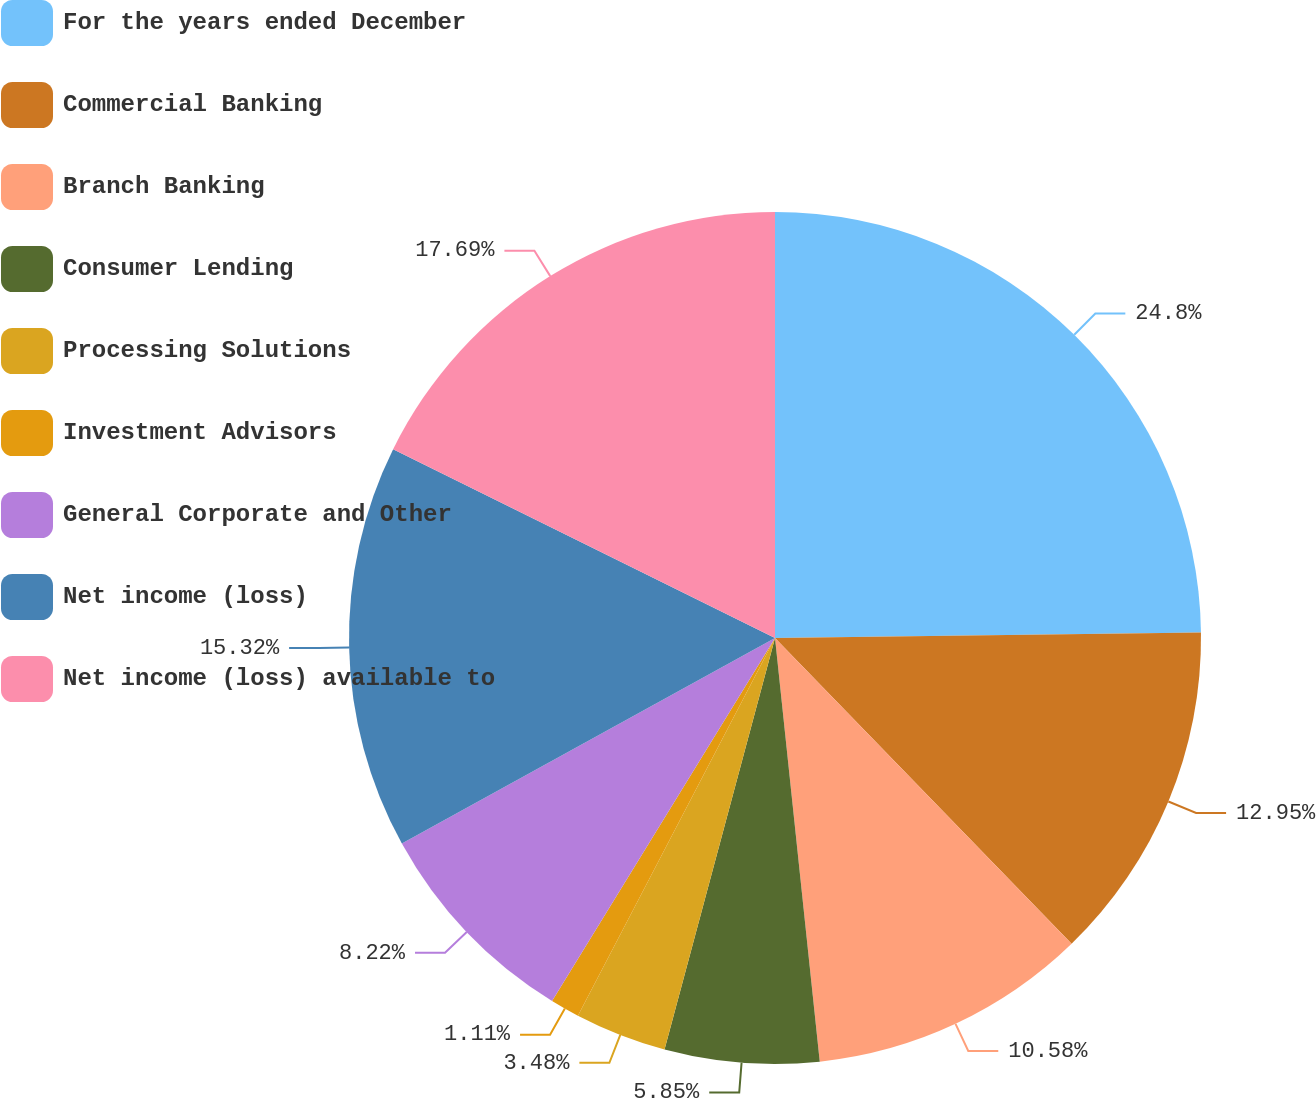<chart> <loc_0><loc_0><loc_500><loc_500><pie_chart><fcel>For the years ended December<fcel>Commercial Banking<fcel>Branch Banking<fcel>Consumer Lending<fcel>Processing Solutions<fcel>Investment Advisors<fcel>General Corporate and Other<fcel>Net income (loss)<fcel>Net income (loss) available to<nl><fcel>24.79%<fcel>12.95%<fcel>10.58%<fcel>5.85%<fcel>3.48%<fcel>1.11%<fcel>8.22%<fcel>15.32%<fcel>17.69%<nl></chart> 